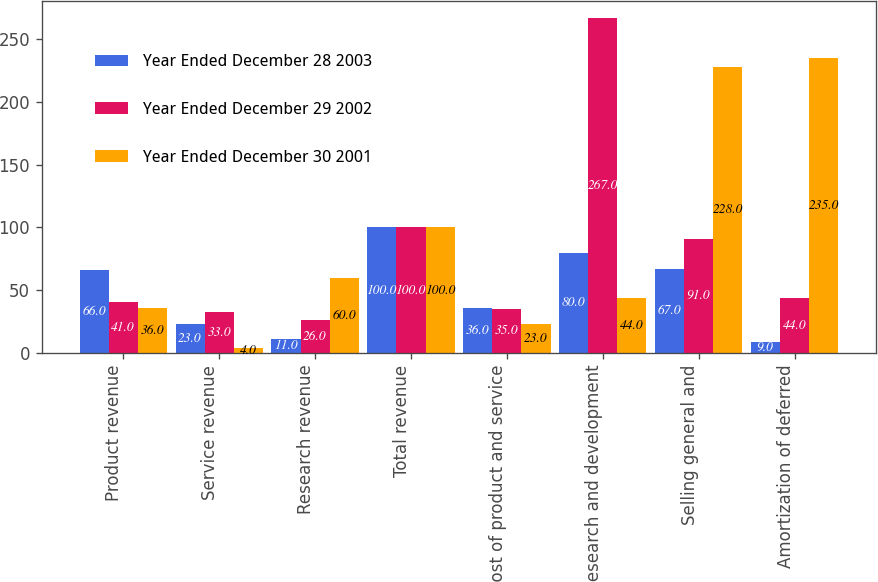Convert chart to OTSL. <chart><loc_0><loc_0><loc_500><loc_500><stacked_bar_chart><ecel><fcel>Product revenue<fcel>Service revenue<fcel>Research revenue<fcel>Total revenue<fcel>Cost of product and service<fcel>Research and development<fcel>Selling general and<fcel>Amortization of deferred<nl><fcel>Year Ended December 28 2003<fcel>66<fcel>23<fcel>11<fcel>100<fcel>36<fcel>80<fcel>67<fcel>9<nl><fcel>Year Ended December 29 2002<fcel>41<fcel>33<fcel>26<fcel>100<fcel>35<fcel>267<fcel>91<fcel>44<nl><fcel>Year Ended December 30 2001<fcel>36<fcel>4<fcel>60<fcel>100<fcel>23<fcel>44<fcel>228<fcel>235<nl></chart> 